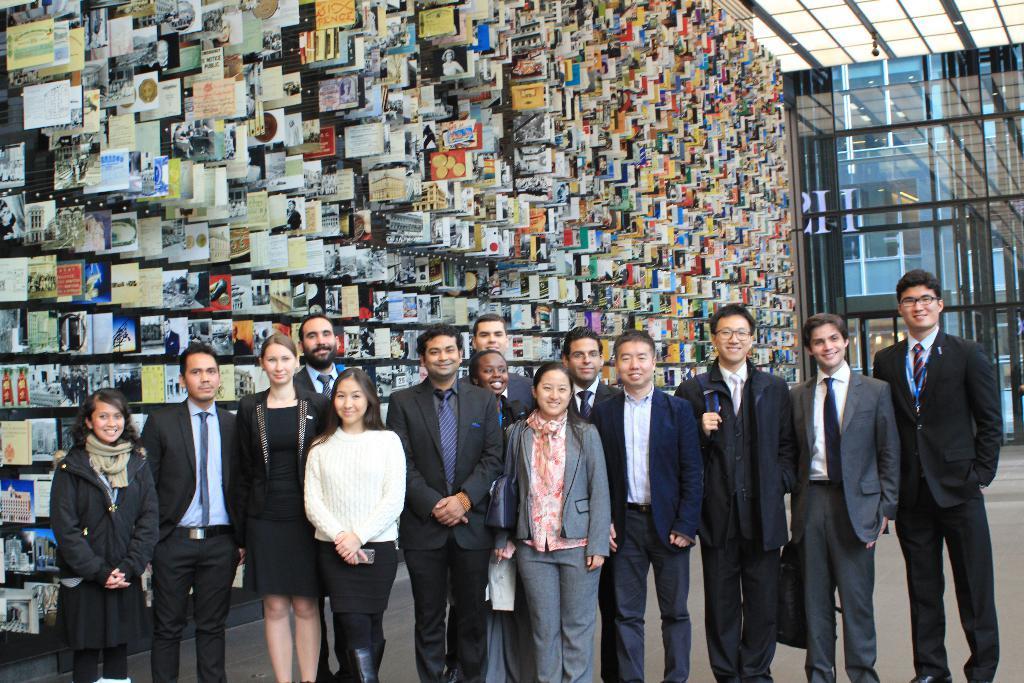How would you summarize this image in a sentence or two? In this image there are group of people standing and smiling inside a building , and in the background there are so many photos attached to the wall, lights. 